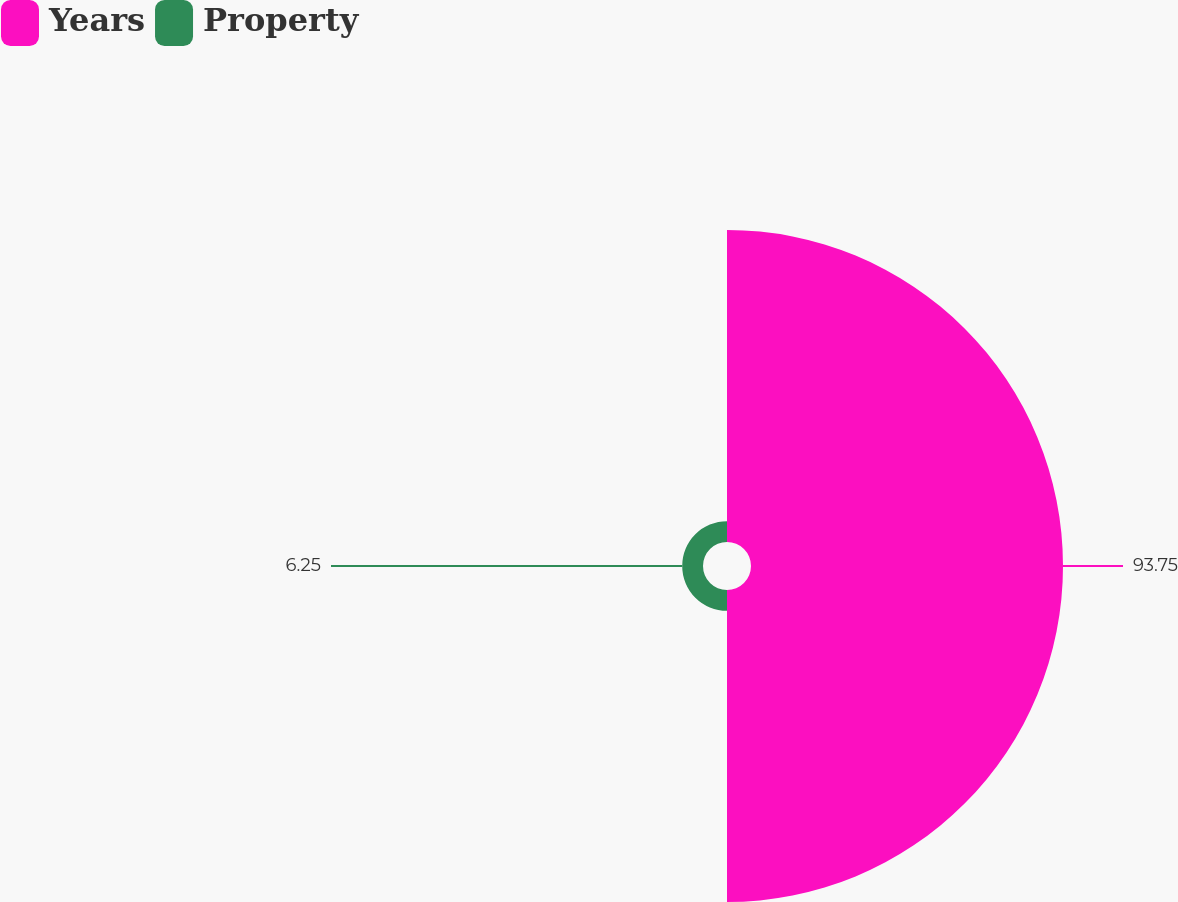<chart> <loc_0><loc_0><loc_500><loc_500><pie_chart><fcel>Years<fcel>Property<nl><fcel>93.75%<fcel>6.25%<nl></chart> 